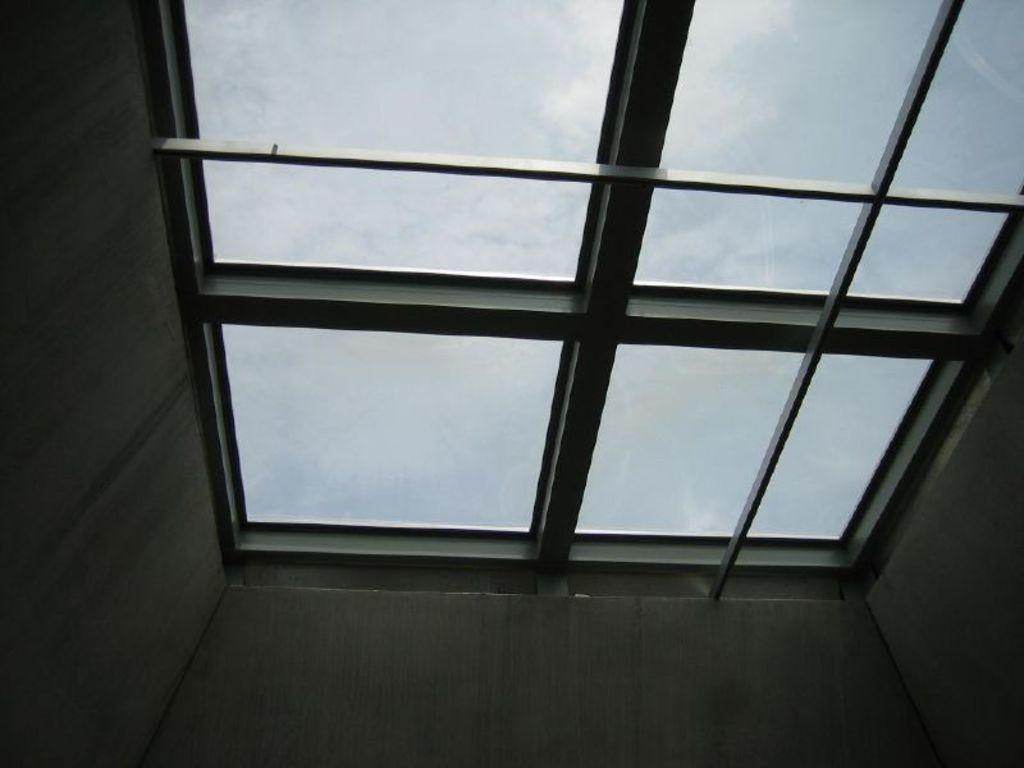What type of opening can be seen in the image? There is a window in the image. Where is the window located in relation to the building? The window is on the roof of a building. What can be seen in the background of the image? The sky is visible in the background of the image. How many brothers are visible in the image? There are no brothers present in the image; it features a window on a roof with a visible sky in the background. 